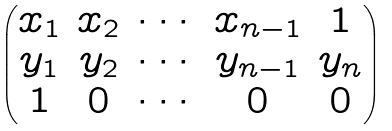<formula> <loc_0><loc_0><loc_500><loc_500>\begin{pmatrix} x _ { 1 } & x _ { 2 } & \cdots & x _ { n - 1 } & 1 \\ y _ { 1 } & y _ { 2 } & \cdots & y _ { n - 1 } & y _ { n } \\ 1 & 0 & \cdots & 0 & 0 \end{pmatrix}</formula> 